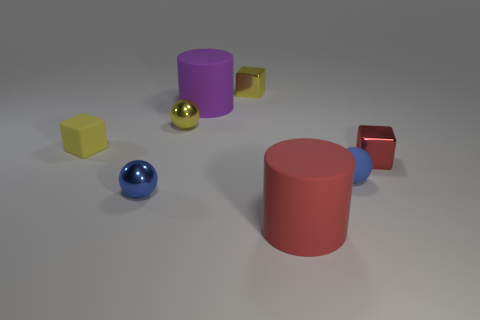There is a red cylinder that is made of the same material as the large purple object; what size is it?
Make the answer very short. Large. The other rubber object that is the same shape as the purple thing is what size?
Make the answer very short. Large. There is a small rubber object that is the same shape as the blue shiny thing; what color is it?
Give a very brief answer. Blue. There is a metallic object that is both in front of the tiny yellow matte cube and behind the tiny blue metal sphere; what shape is it?
Your answer should be compact. Cube. What material is the big object that is on the left side of the shiny block that is behind the small rubber cube to the left of the red shiny object?
Offer a terse response. Rubber. Is the number of yellow things on the left side of the small blue metallic object greater than the number of red metallic blocks that are to the left of the small red metal object?
Keep it short and to the point. Yes. How many large things have the same material as the tiny yellow ball?
Make the answer very short. 0. There is a large thing that is behind the small yellow rubber thing; is its shape the same as the red thing that is in front of the small red thing?
Keep it short and to the point. Yes. What color is the cylinder in front of the purple rubber thing?
Offer a very short reply. Red. Is there a purple rubber thing of the same shape as the large red thing?
Keep it short and to the point. Yes. 